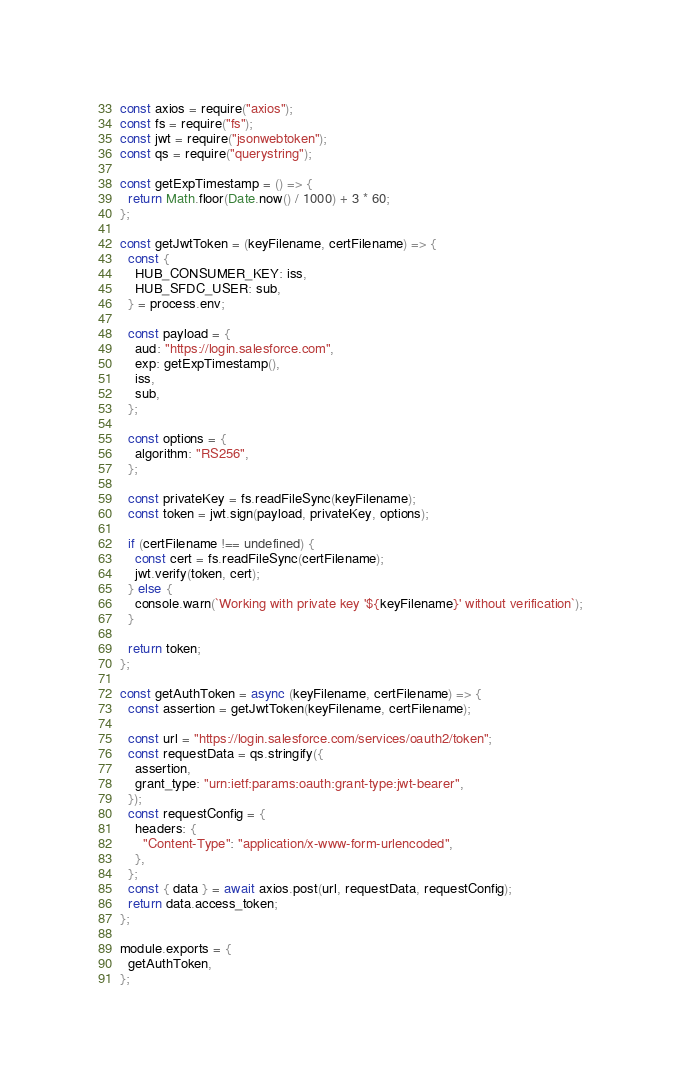<code> <loc_0><loc_0><loc_500><loc_500><_JavaScript_>const axios = require("axios");
const fs = require("fs");
const jwt = require("jsonwebtoken");
const qs = require("querystring");

const getExpTimestamp = () => {
  return Math.floor(Date.now() / 1000) + 3 * 60;
};

const getJwtToken = (keyFilename, certFilename) => {
  const {
    HUB_CONSUMER_KEY: iss,
    HUB_SFDC_USER: sub,
  } = process.env;

  const payload = {
    aud: "https://login.salesforce.com",
    exp: getExpTimestamp(),
    iss,
    sub,
  };

  const options = {
    algorithm: "RS256",
  };

  const privateKey = fs.readFileSync(keyFilename);
  const token = jwt.sign(payload, privateKey, options);

  if (certFilename !== undefined) {
    const cert = fs.readFileSync(certFilename);
    jwt.verify(token, cert);
  } else {
    console.warn(`Working with private key '${keyFilename}' without verification`);
  }

  return token;
};

const getAuthToken = async (keyFilename, certFilename) => {
  const assertion = getJwtToken(keyFilename, certFilename);

  const url = "https://login.salesforce.com/services/oauth2/token";
  const requestData = qs.stringify({
    assertion,
    grant_type: "urn:ietf:params:oauth:grant-type:jwt-bearer",
  });
  const requestConfig = {
    headers: {
      "Content-Type": "application/x-www-form-urlencoded",
    },
  };
  const { data } = await axios.post(url, requestData, requestConfig);
  return data.access_token;
};

module.exports = {
  getAuthToken,
};
</code> 